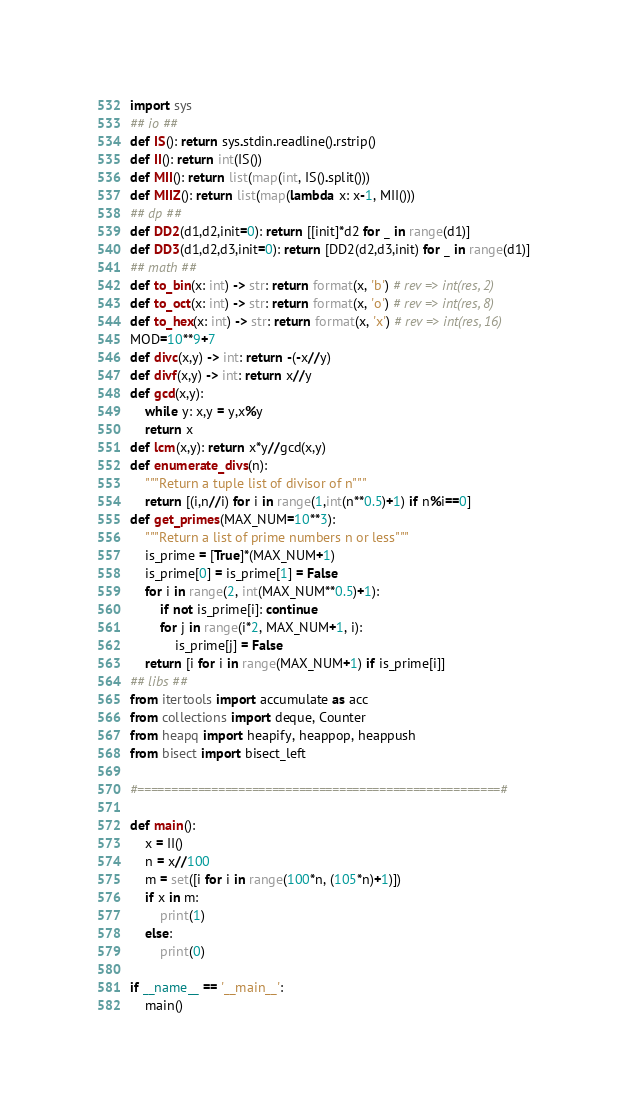Convert code to text. <code><loc_0><loc_0><loc_500><loc_500><_Python_>import sys
## io ##
def IS(): return sys.stdin.readline().rstrip()
def II(): return int(IS())
def MII(): return list(map(int, IS().split()))
def MIIZ(): return list(map(lambda x: x-1, MII()))
## dp ##
def DD2(d1,d2,init=0): return [[init]*d2 for _ in range(d1)]
def DD3(d1,d2,d3,init=0): return [DD2(d2,d3,init) for _ in range(d1)]
## math ##
def to_bin(x: int) -> str: return format(x, 'b') # rev => int(res, 2)
def to_oct(x: int) -> str: return format(x, 'o') # rev => int(res, 8)
def to_hex(x: int) -> str: return format(x, 'x') # rev => int(res, 16)
MOD=10**9+7
def divc(x,y) -> int: return -(-x//y)
def divf(x,y) -> int: return x//y
def gcd(x,y):
    while y: x,y = y,x%y
    return x
def lcm(x,y): return x*y//gcd(x,y)
def enumerate_divs(n):
    """Return a tuple list of divisor of n"""
    return [(i,n//i) for i in range(1,int(n**0.5)+1) if n%i==0]
def get_primes(MAX_NUM=10**3):
    """Return a list of prime numbers n or less"""
    is_prime = [True]*(MAX_NUM+1)
    is_prime[0] = is_prime[1] = False
    for i in range(2, int(MAX_NUM**0.5)+1):
        if not is_prime[i]: continue
        for j in range(i*2, MAX_NUM+1, i):
            is_prime[j] = False
    return [i for i in range(MAX_NUM+1) if is_prime[i]]
## libs ##
from itertools import accumulate as acc
from collections import deque, Counter
from heapq import heapify, heappop, heappush
from bisect import bisect_left

#======================================================#

def main():
    x = II()
    n = x//100
    m = set([i for i in range(100*n, (105*n)+1)])
    if x in m:
        print(1)
    else:
        print(0)

if __name__ == '__main__':
    main()</code> 